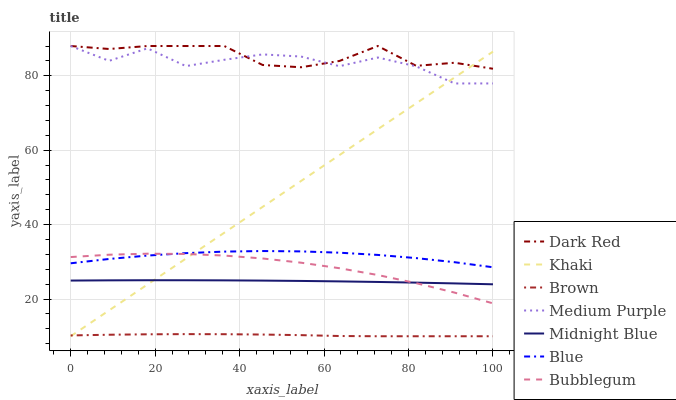Does Khaki have the minimum area under the curve?
Answer yes or no. No. Does Khaki have the maximum area under the curve?
Answer yes or no. No. Is Brown the smoothest?
Answer yes or no. No. Is Brown the roughest?
Answer yes or no. No. Does Midnight Blue have the lowest value?
Answer yes or no. No. Does Khaki have the highest value?
Answer yes or no. No. Is Midnight Blue less than Medium Purple?
Answer yes or no. Yes. Is Dark Red greater than Bubblegum?
Answer yes or no. Yes. Does Midnight Blue intersect Medium Purple?
Answer yes or no. No. 